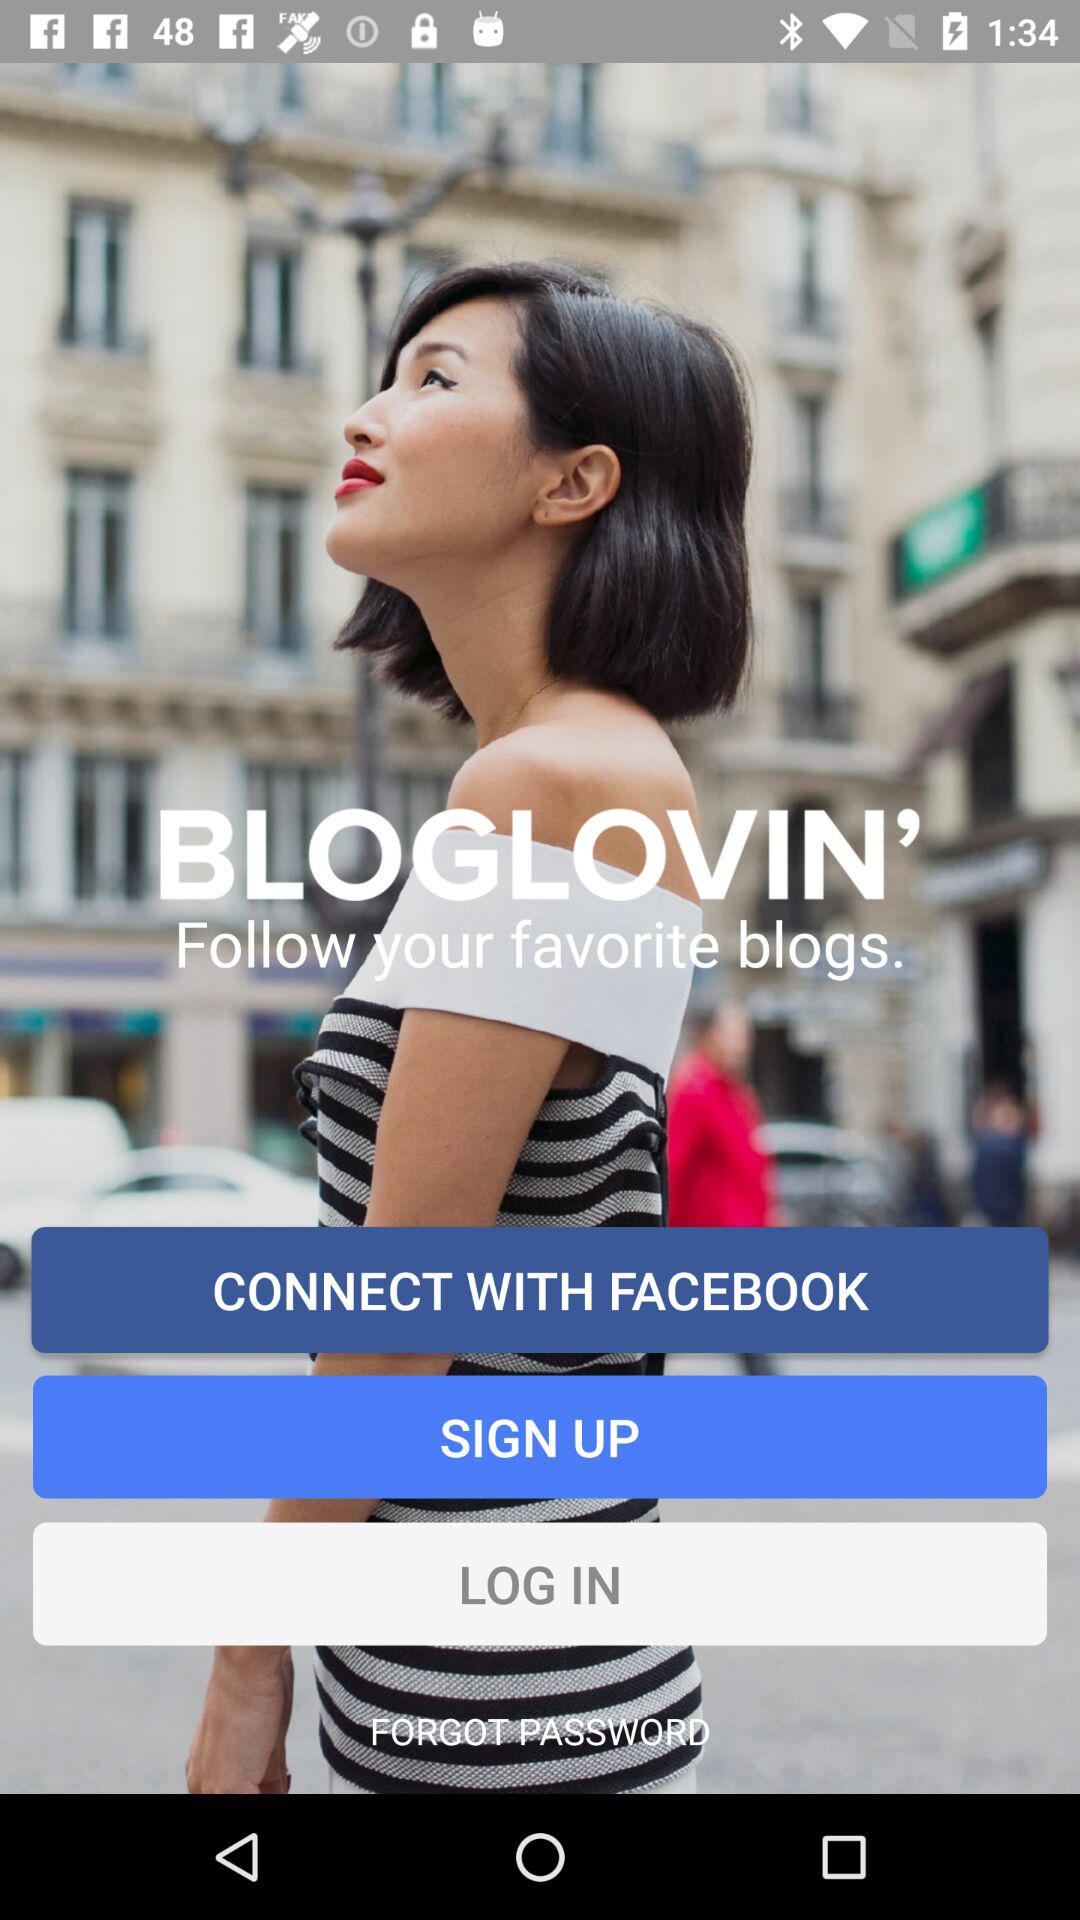Through what account can the user connect? The user can connect using their Facebook account, as indicated by the prominent 'CONNECT WITH FACEBOOK' button displayed on the application screen. This feature simplifies the login process, allowing users to access the platform using their existing Facebook credentials, thereby enhancing user convenience and streamlining the sign-in procedure. 